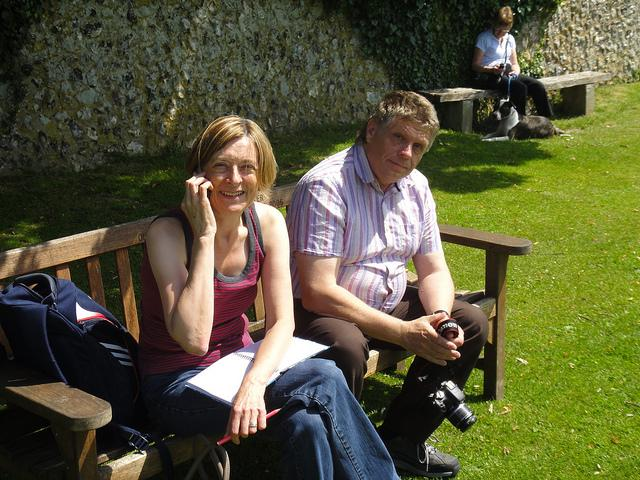What is the woman wearing sleeveless shirt doing? smiling 